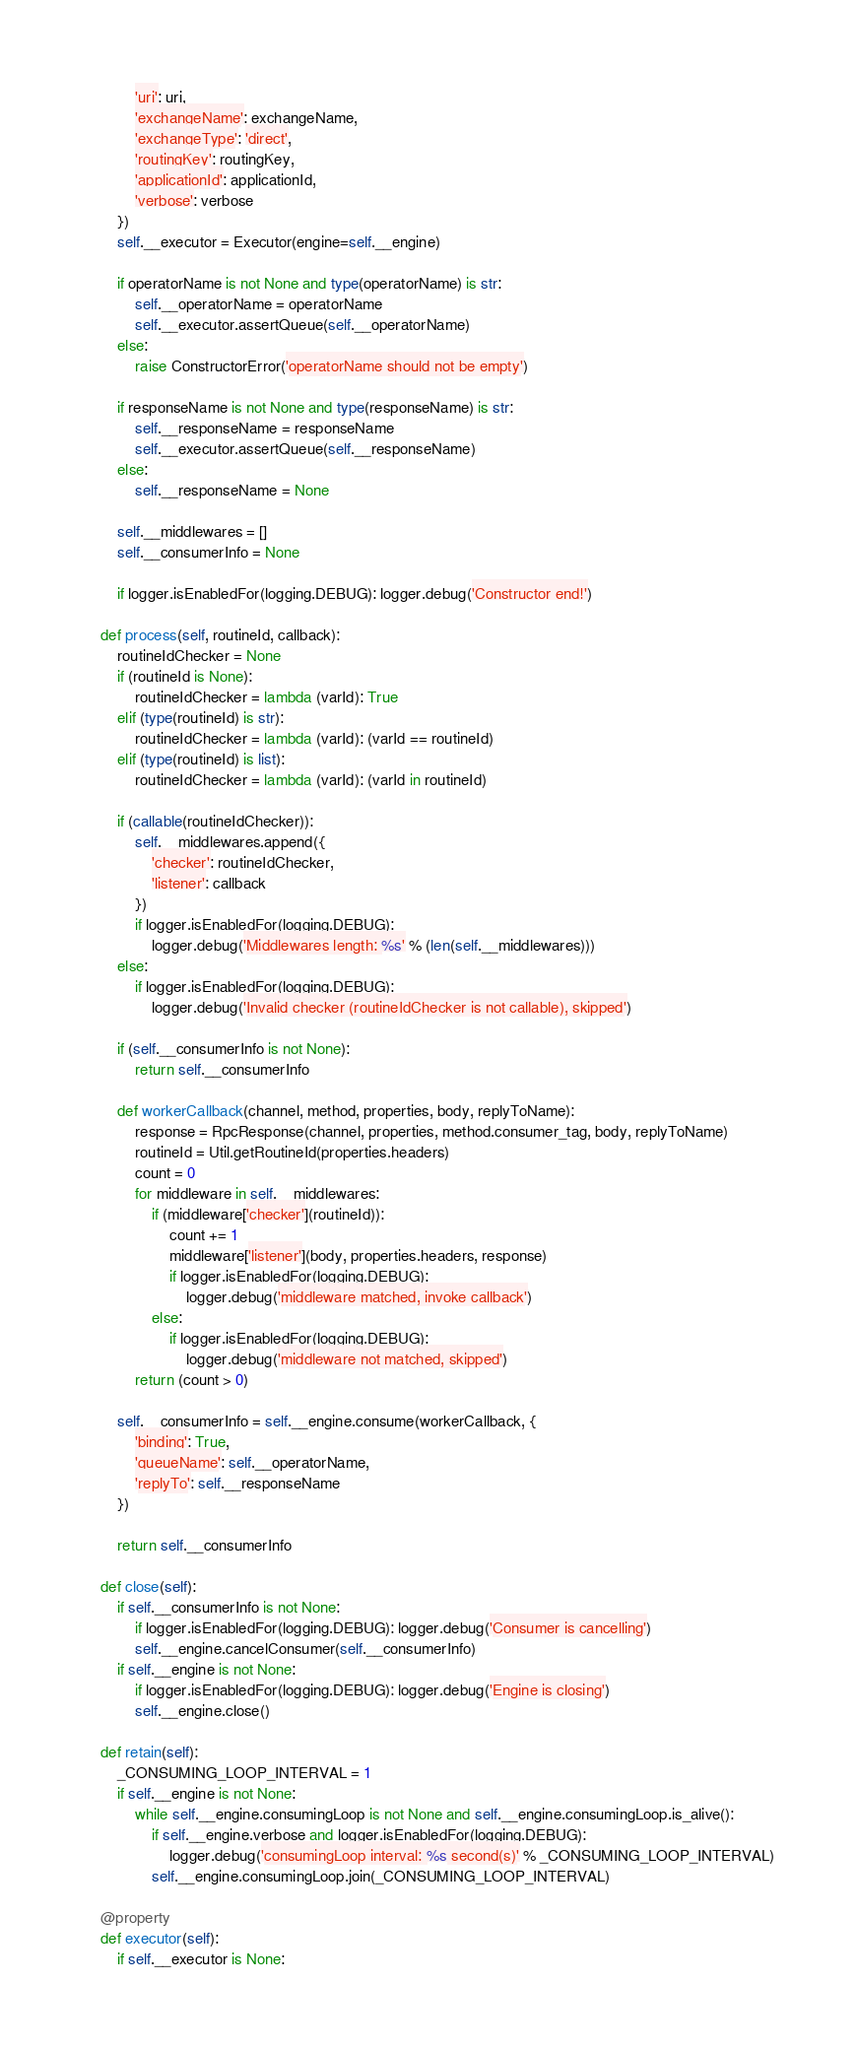<code> <loc_0><loc_0><loc_500><loc_500><_Python_>            'uri': uri, 
            'exchangeName': exchangeName,
            'exchangeType': 'direct',
            'routingKey': routingKey,
            'applicationId': applicationId,
            'verbose': verbose
        })
        self.__executor = Executor(engine=self.__engine)

        if operatorName is not None and type(operatorName) is str:
            self.__operatorName = operatorName
            self.__executor.assertQueue(self.__operatorName)
        else:
            raise ConstructorError('operatorName should not be empty')

        if responseName is not None and type(responseName) is str:
            self.__responseName = responseName
            self.__executor.assertQueue(self.__responseName)
        else:
            self.__responseName = None

        self.__middlewares = []
        self.__consumerInfo = None

        if logger.isEnabledFor(logging.DEBUG): logger.debug('Constructor end!')

    def process(self, routineId, callback):
        routineIdChecker = None
        if (routineId is None):
            routineIdChecker = lambda (varId): True
        elif (type(routineId) is str):
            routineIdChecker = lambda (varId): (varId == routineId)
        elif (type(routineId) is list):
            routineIdChecker = lambda (varId): (varId in routineId)

        if (callable(routineIdChecker)):
            self.__middlewares.append({
                'checker': routineIdChecker,
                'listener': callback
            })
            if logger.isEnabledFor(logging.DEBUG):
                logger.debug('Middlewares length: %s' % (len(self.__middlewares)))
        else:
            if logger.isEnabledFor(logging.DEBUG):
                logger.debug('Invalid checker (routineIdChecker is not callable), skipped')

        if (self.__consumerInfo is not None):
            return self.__consumerInfo

        def workerCallback(channel, method, properties, body, replyToName):
            response = RpcResponse(channel, properties, method.consumer_tag, body, replyToName)
            routineId = Util.getRoutineId(properties.headers)
            count = 0
            for middleware in self.__middlewares:
                if (middleware['checker'](routineId)):
                    count += 1
                    middleware['listener'](body, properties.headers, response)
                    if logger.isEnabledFor(logging.DEBUG):
                        logger.debug('middleware matched, invoke callback')
                else:
                    if logger.isEnabledFor(logging.DEBUG):
                        logger.debug('middleware not matched, skipped')
            return (count > 0)

        self.__consumerInfo = self.__engine.consume(workerCallback, {
            'binding': True,
            'queueName': self.__operatorName,
            'replyTo': self.__responseName
        })

        return self.__consumerInfo

    def close(self):
        if self.__consumerInfo is not None:
            if logger.isEnabledFor(logging.DEBUG): logger.debug('Consumer is cancelling')
            self.__engine.cancelConsumer(self.__consumerInfo)
        if self.__engine is not None:
            if logger.isEnabledFor(logging.DEBUG): logger.debug('Engine is closing')
            self.__engine.close()

    def retain(self):
        _CONSUMING_LOOP_INTERVAL = 1
        if self.__engine is not None:
            while self.__engine.consumingLoop is not None and self.__engine.consumingLoop.is_alive():
                if self.__engine.verbose and logger.isEnabledFor(logging.DEBUG):
                    logger.debug('consumingLoop interval: %s second(s)' % _CONSUMING_LOOP_INTERVAL)
                self.__engine.consumingLoop.join(_CONSUMING_LOOP_INTERVAL)

    @property
    def executor(self):
        if self.__executor is None:</code> 